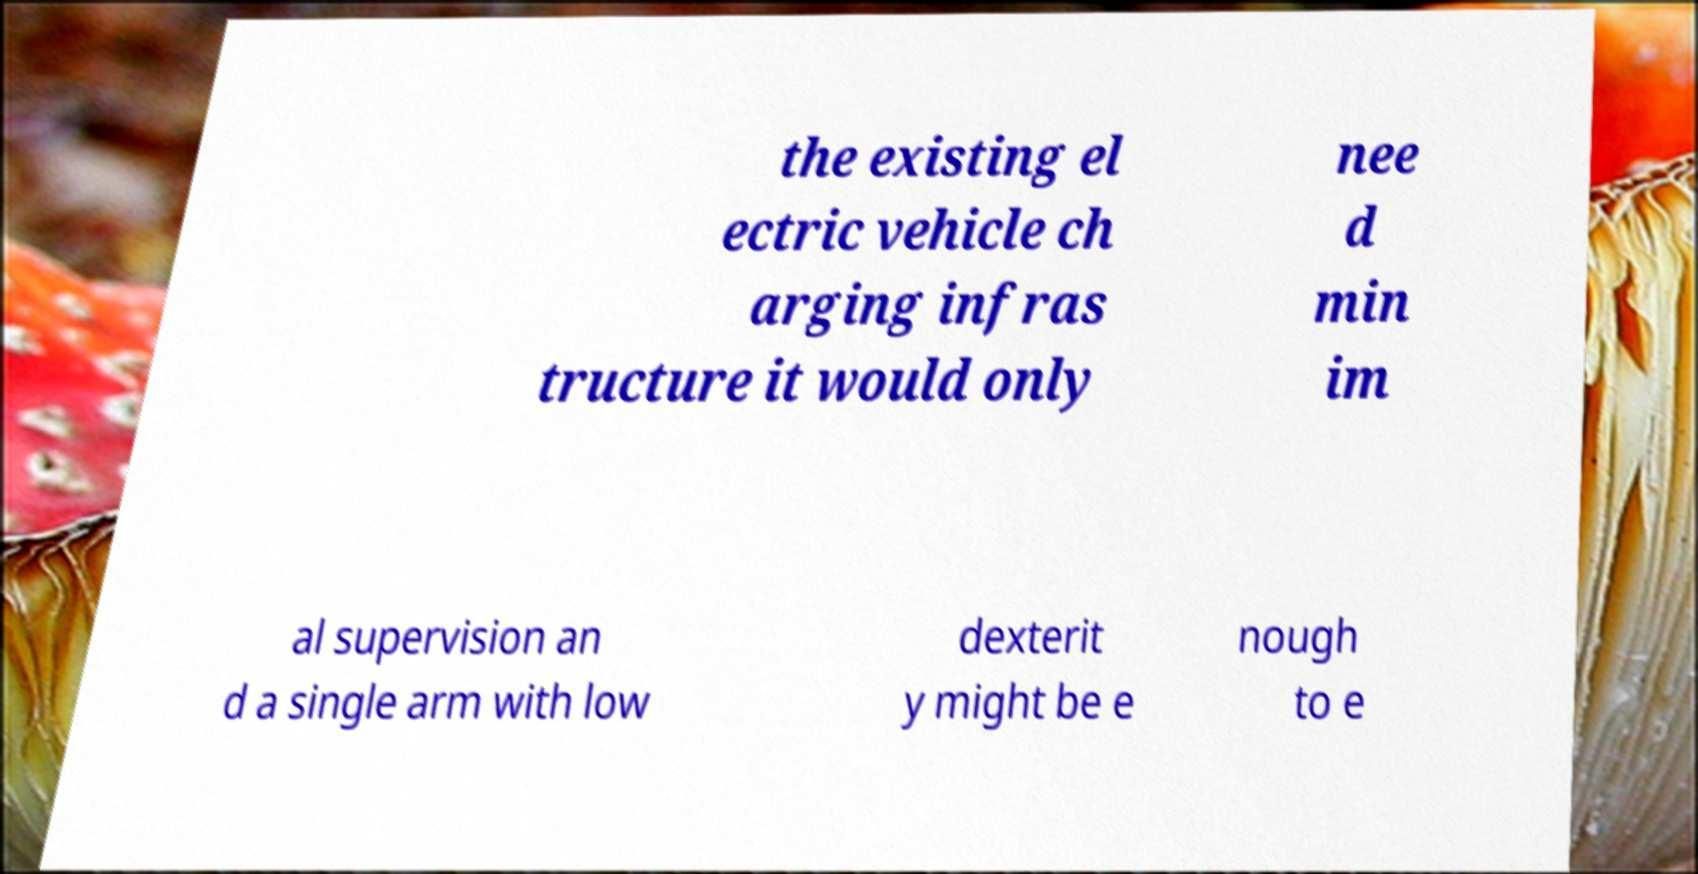For documentation purposes, I need the text within this image transcribed. Could you provide that? the existing el ectric vehicle ch arging infras tructure it would only nee d min im al supervision an d a single arm with low dexterit y might be e nough to e 